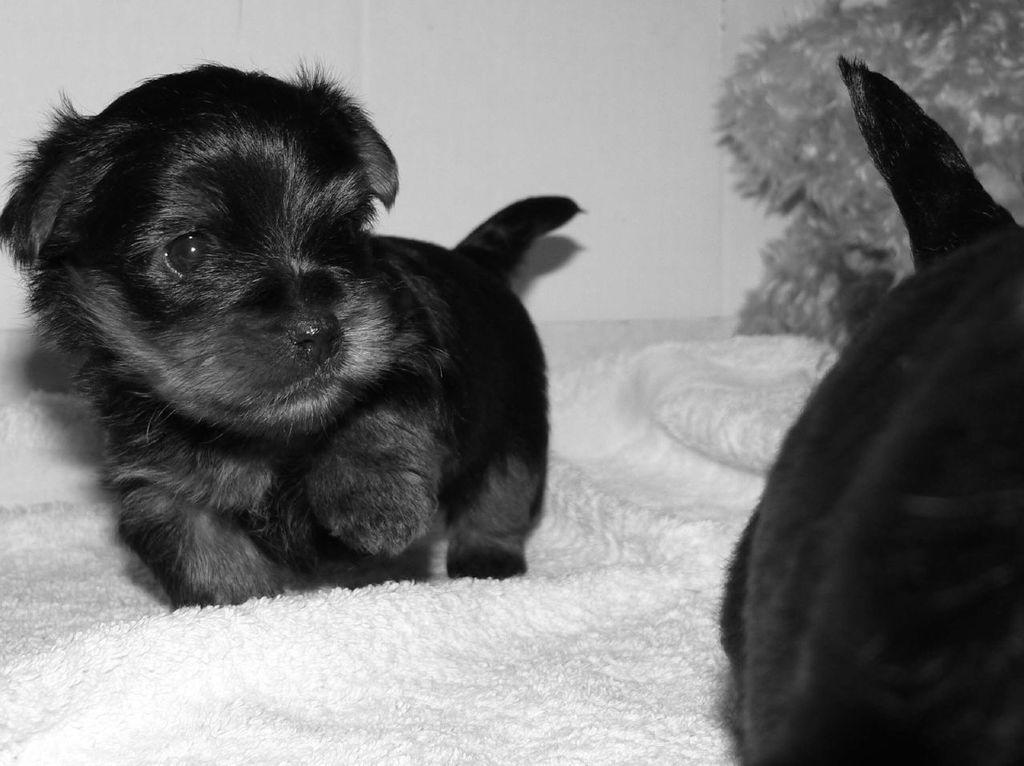Could you give a brief overview of what you see in this image? Black and white picture. On this cloth surface we can see puppies. Background there is a white wall. 